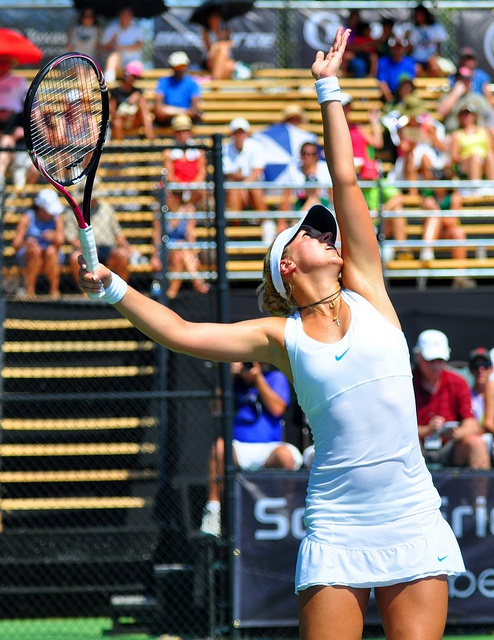Describe the objects in this image and their specific colors. I can see people in lightblue, white, tan, and black tones, tennis racket in lightblue, black, gray, darkgray, and brown tones, bench in lightblue, black, and tan tones, bench in lightblue, tan, and olive tones, and people in lightblue, brown, maroon, black, and white tones in this image. 